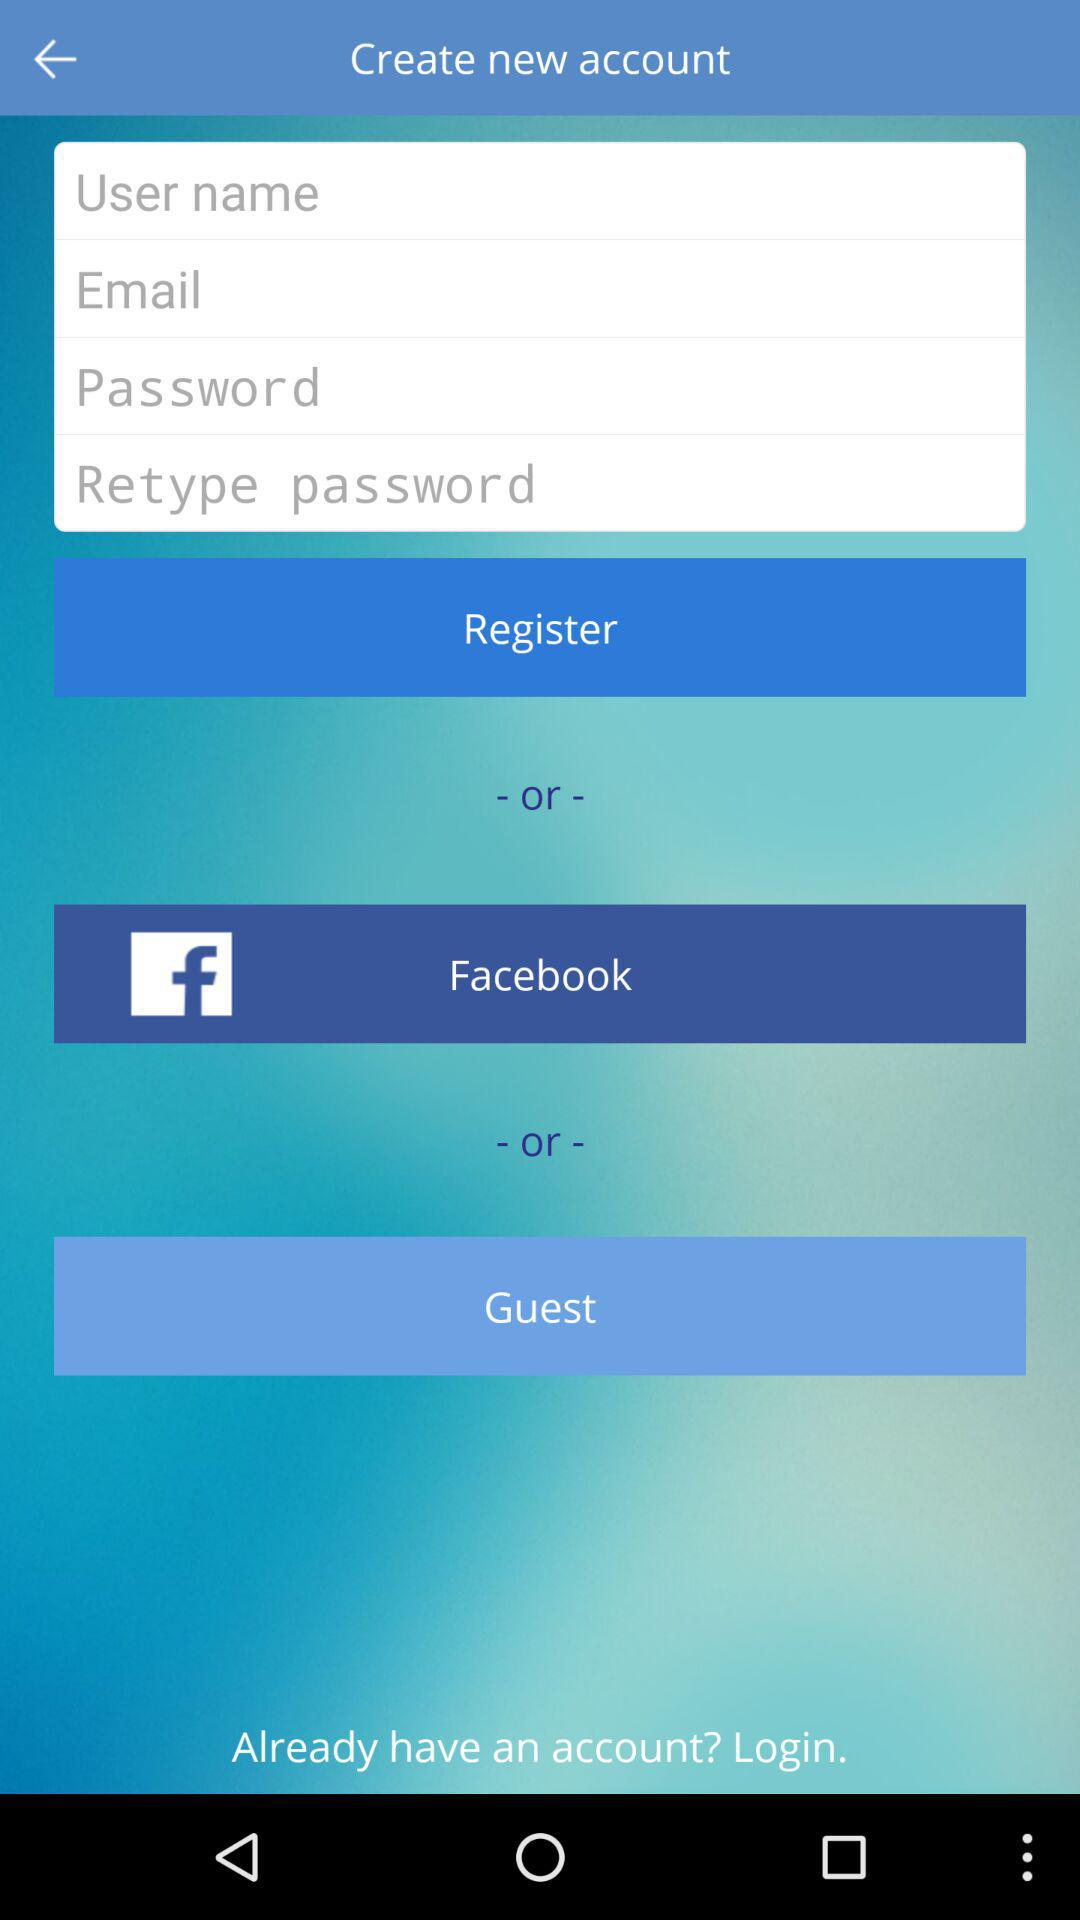What application can we use for login? The application is Facebook. 